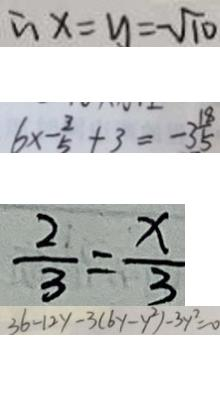Convert formula to latex. <formula><loc_0><loc_0><loc_500><loc_500>\therefore x = y = - \sqrt { 1 0 } 
 6 \times - \frac { 3 } { 5 } + 3 = - 3 \frac { 1 8 } { 5 } 
 \frac { 2 } { 3 } = \frac { x } { 3 } 
 3 6 - 1 2 y - 3 ( 6 y - y ^ { 2 } ) - 3 y ^ { 2 } = 0</formula> 